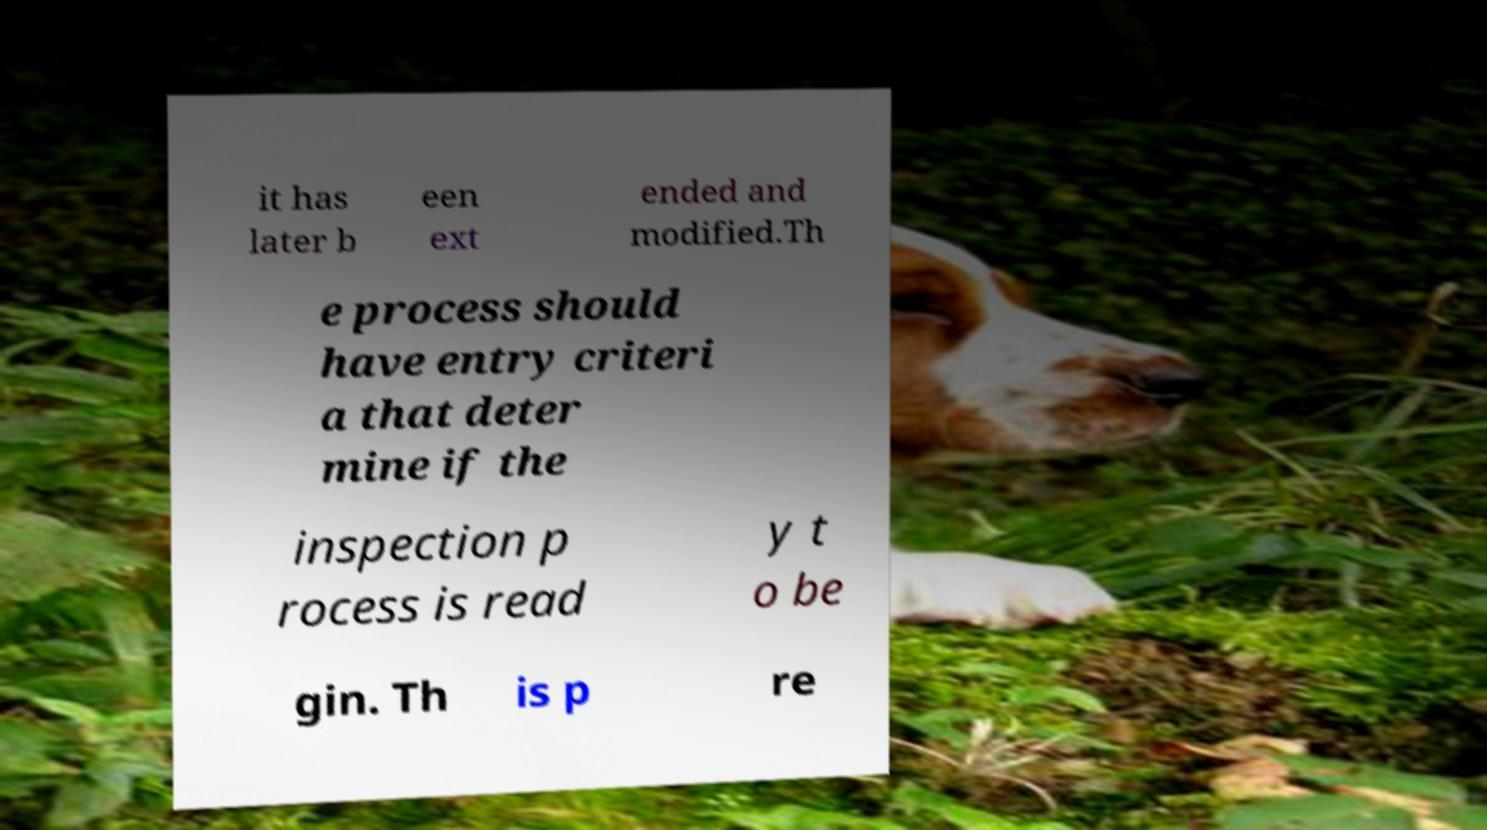For documentation purposes, I need the text within this image transcribed. Could you provide that? it has later b een ext ended and modified.Th e process should have entry criteri a that deter mine if the inspection p rocess is read y t o be gin. Th is p re 